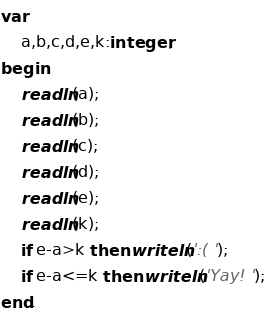<code> <loc_0><loc_0><loc_500><loc_500><_Pascal_>var
    a,b,c,d,e,k:integer;
begin
    readln(a);
    readln(b);
    readln(c);
    readln(d);
    readln(e);
    readln(k);
    if e-a>k then writeln(':( ');
    if e-a<=k then writeln('Yay! ');
end.</code> 